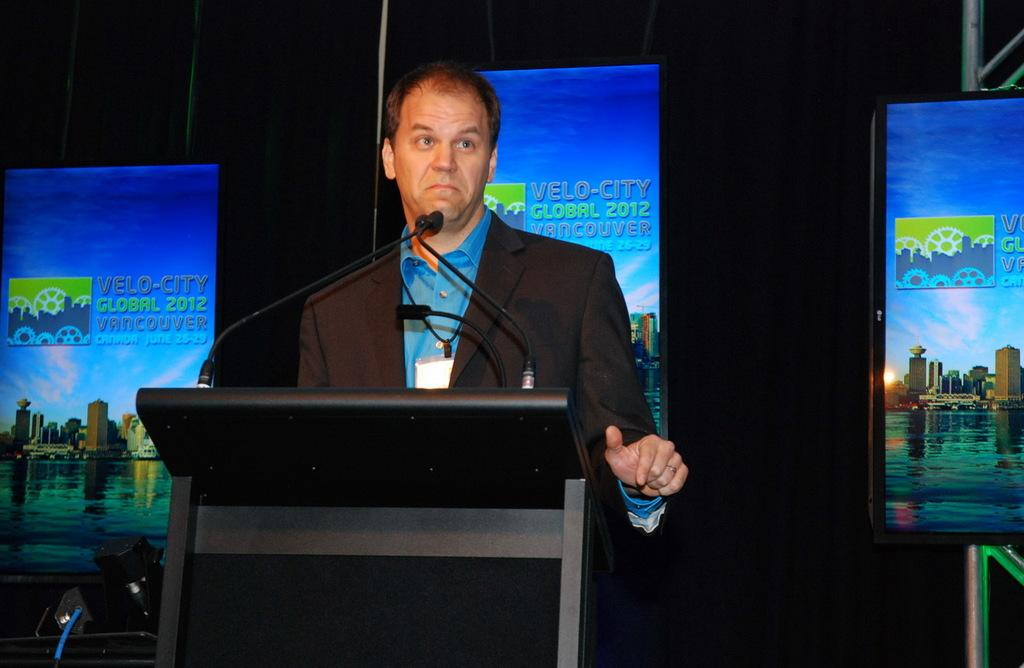<image>
Create a compact narrative representing the image presented. A speaker presents at the Velo-City Global 2012 Vancouver event. 